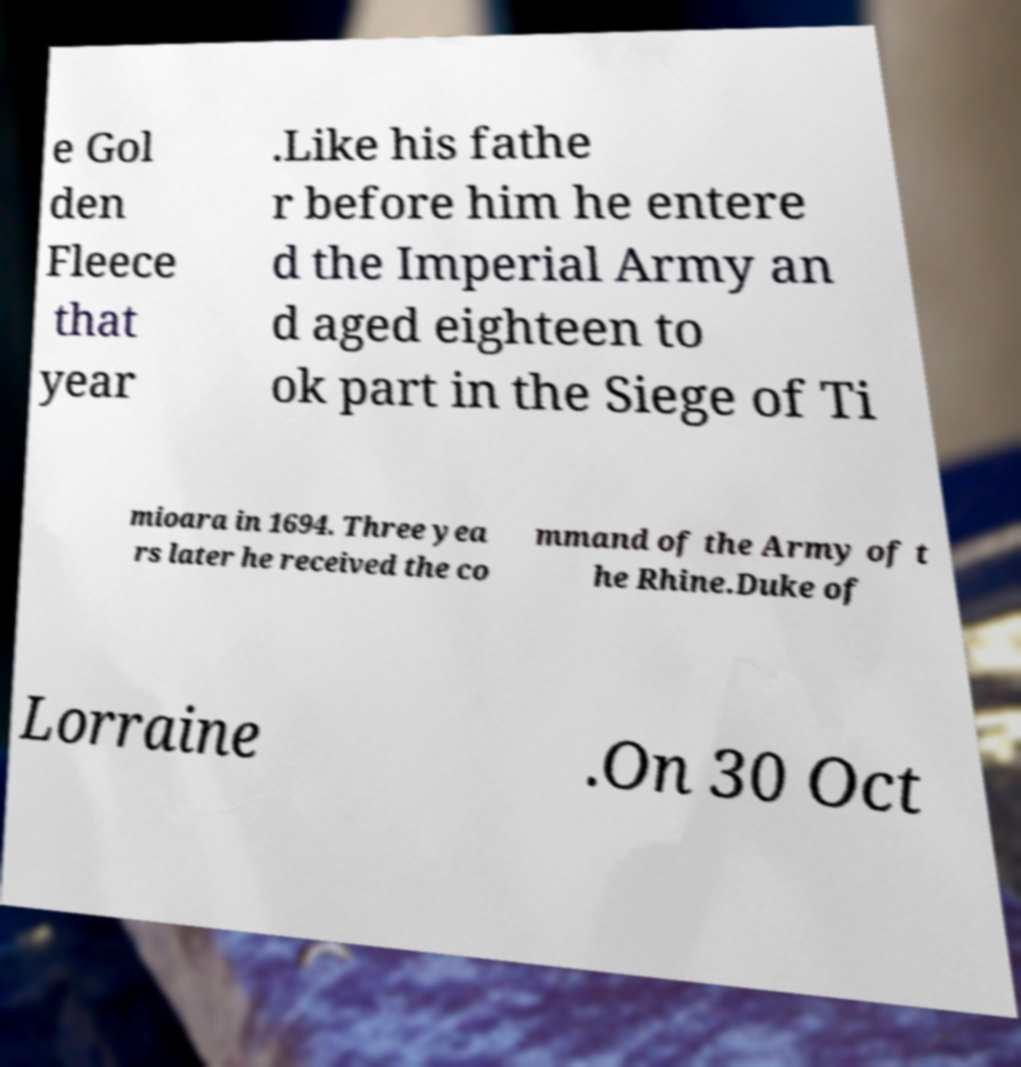Please read and relay the text visible in this image. What does it say? e Gol den Fleece that year .Like his fathe r before him he entere d the Imperial Army an d aged eighteen to ok part in the Siege of Ti mioara in 1694. Three yea rs later he received the co mmand of the Army of t he Rhine.Duke of Lorraine .On 30 Oct 